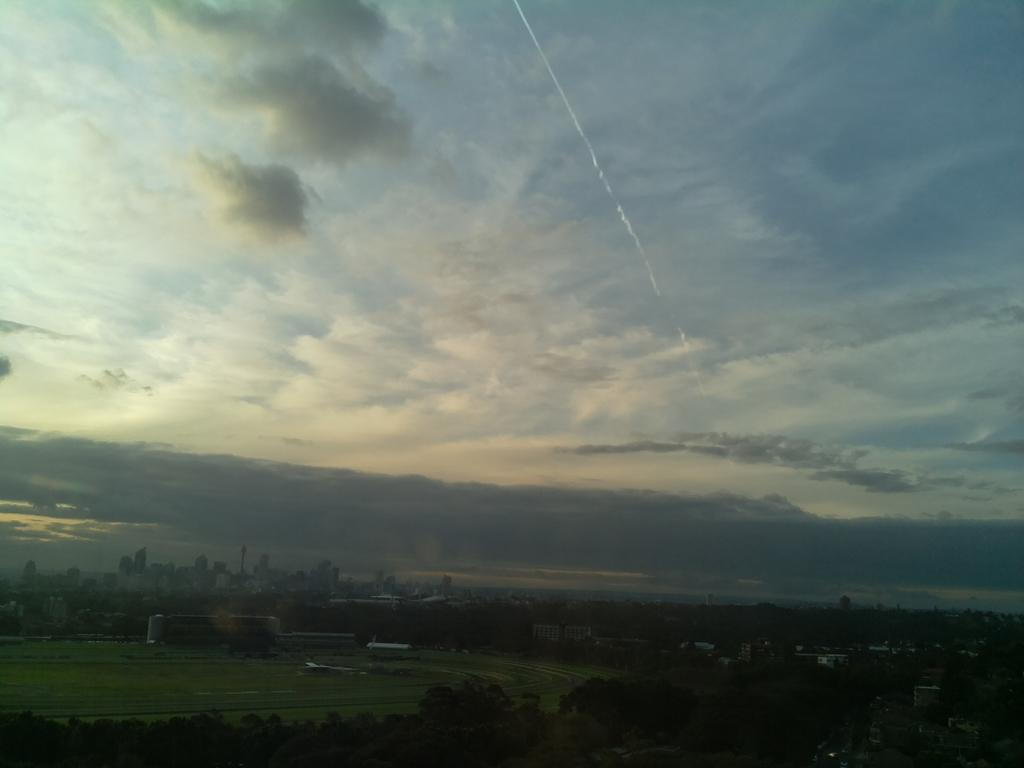What type of vegetation can be seen in the image? There is a group of trees in the image. What structures are present in the image? There are buildings in the image. What is visible at the top of the image? The sky is visible at the top of the image. What type of jewel is hanging from the tallest tree in the image? There is no jewel present in the image; it features a group of trees and buildings. How many pins can be seen securing the buildings to the ground in the image? There are no pins visible in the image; the buildings are not depicted as being secured to the ground. 